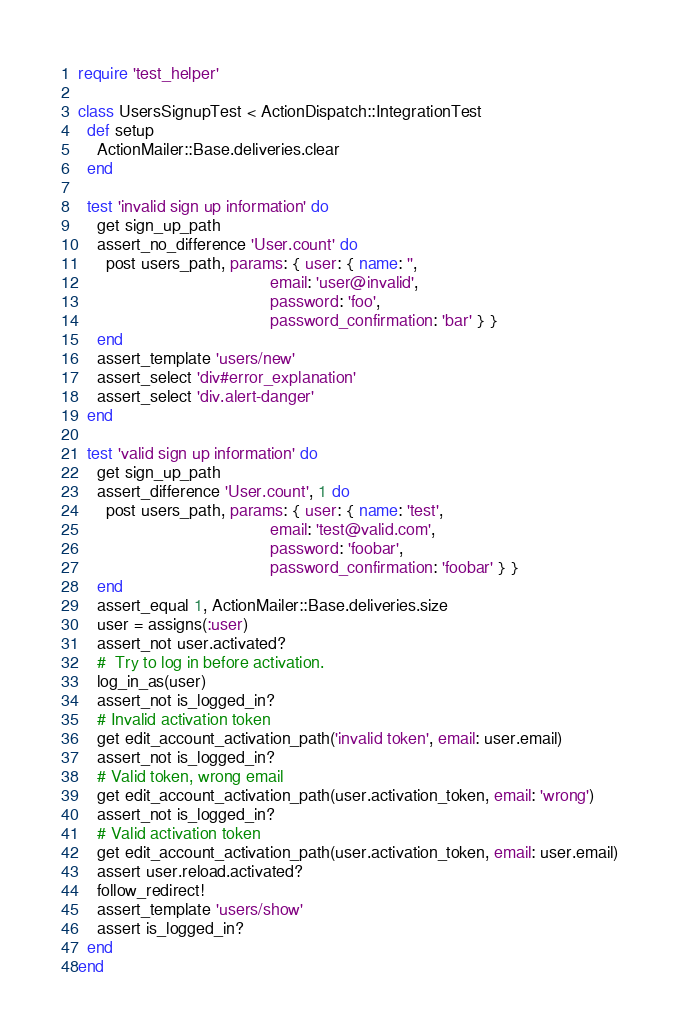<code> <loc_0><loc_0><loc_500><loc_500><_Ruby_>require 'test_helper'

class UsersSignupTest < ActionDispatch::IntegrationTest
  def setup
    ActionMailer::Base.deliveries.clear
  end

  test 'invalid sign up information' do
    get sign_up_path
    assert_no_difference 'User.count' do
      post users_path, params: { user: { name: '',
                                         email: 'user@invalid',
                                         password: 'foo',
                                         password_confirmation: 'bar' } }
    end
    assert_template 'users/new'
    assert_select 'div#error_explanation'
    assert_select 'div.alert-danger'
  end

  test 'valid sign up information' do
    get sign_up_path
    assert_difference 'User.count', 1 do
      post users_path, params: { user: { name: 'test',
                                         email: 'test@valid.com',
                                         password: 'foobar',
                                         password_confirmation: 'foobar' } }
    end
    assert_equal 1, ActionMailer::Base.deliveries.size
    user = assigns(:user)
    assert_not user.activated?
    #  Try to log in before activation.
    log_in_as(user)
    assert_not is_logged_in?
    # Invalid activation token
    get edit_account_activation_path('invalid token', email: user.email)
    assert_not is_logged_in?
    # Valid token, wrong email
    get edit_account_activation_path(user.activation_token, email: 'wrong')
    assert_not is_logged_in?
    # Valid activation token
    get edit_account_activation_path(user.activation_token, email: user.email)
    assert user.reload.activated?
    follow_redirect!
    assert_template 'users/show'
    assert is_logged_in?
  end
end
</code> 